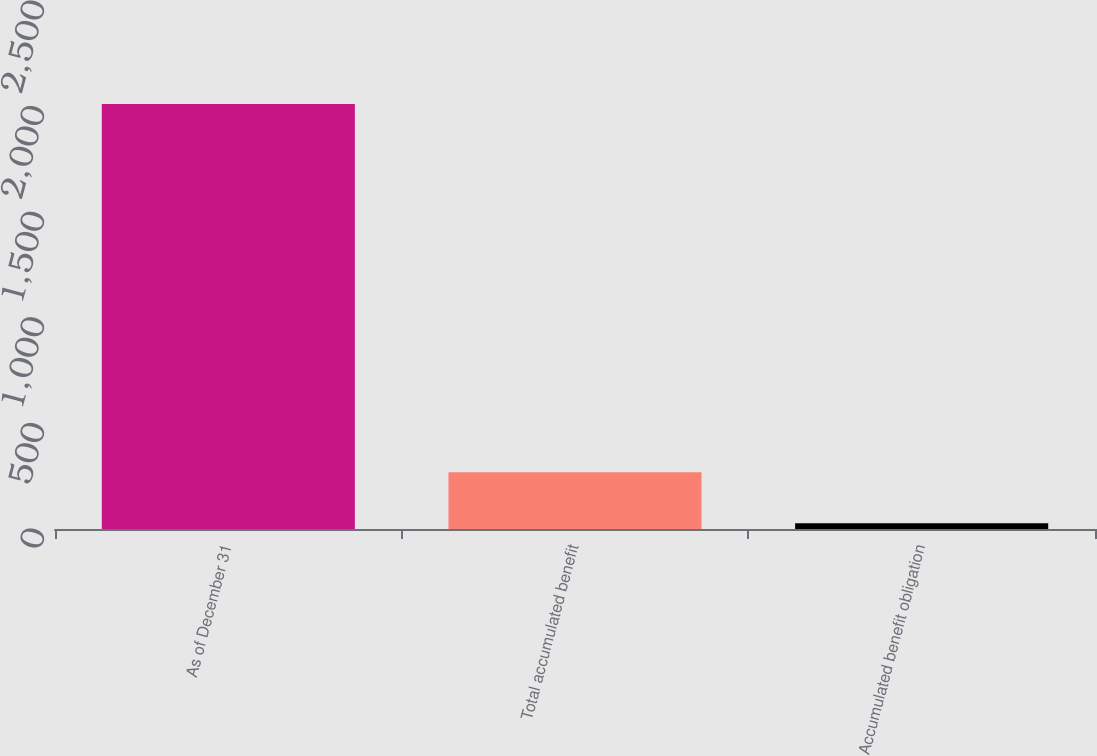<chart> <loc_0><loc_0><loc_500><loc_500><bar_chart><fcel>As of December 31<fcel>Total accumulated benefit<fcel>Accumulated benefit obligation<nl><fcel>2012<fcel>268.7<fcel>26.9<nl></chart> 